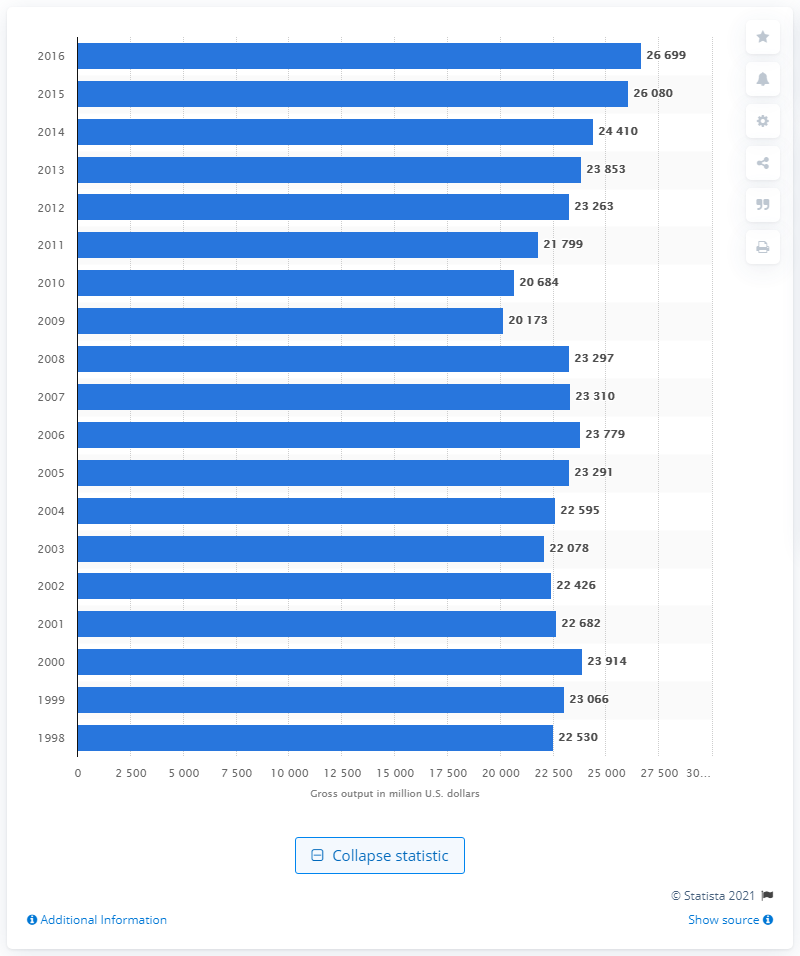Specify some key components in this picture. In 2016, the gross output of the glass and glass product manufacturing sector was 26,699. 